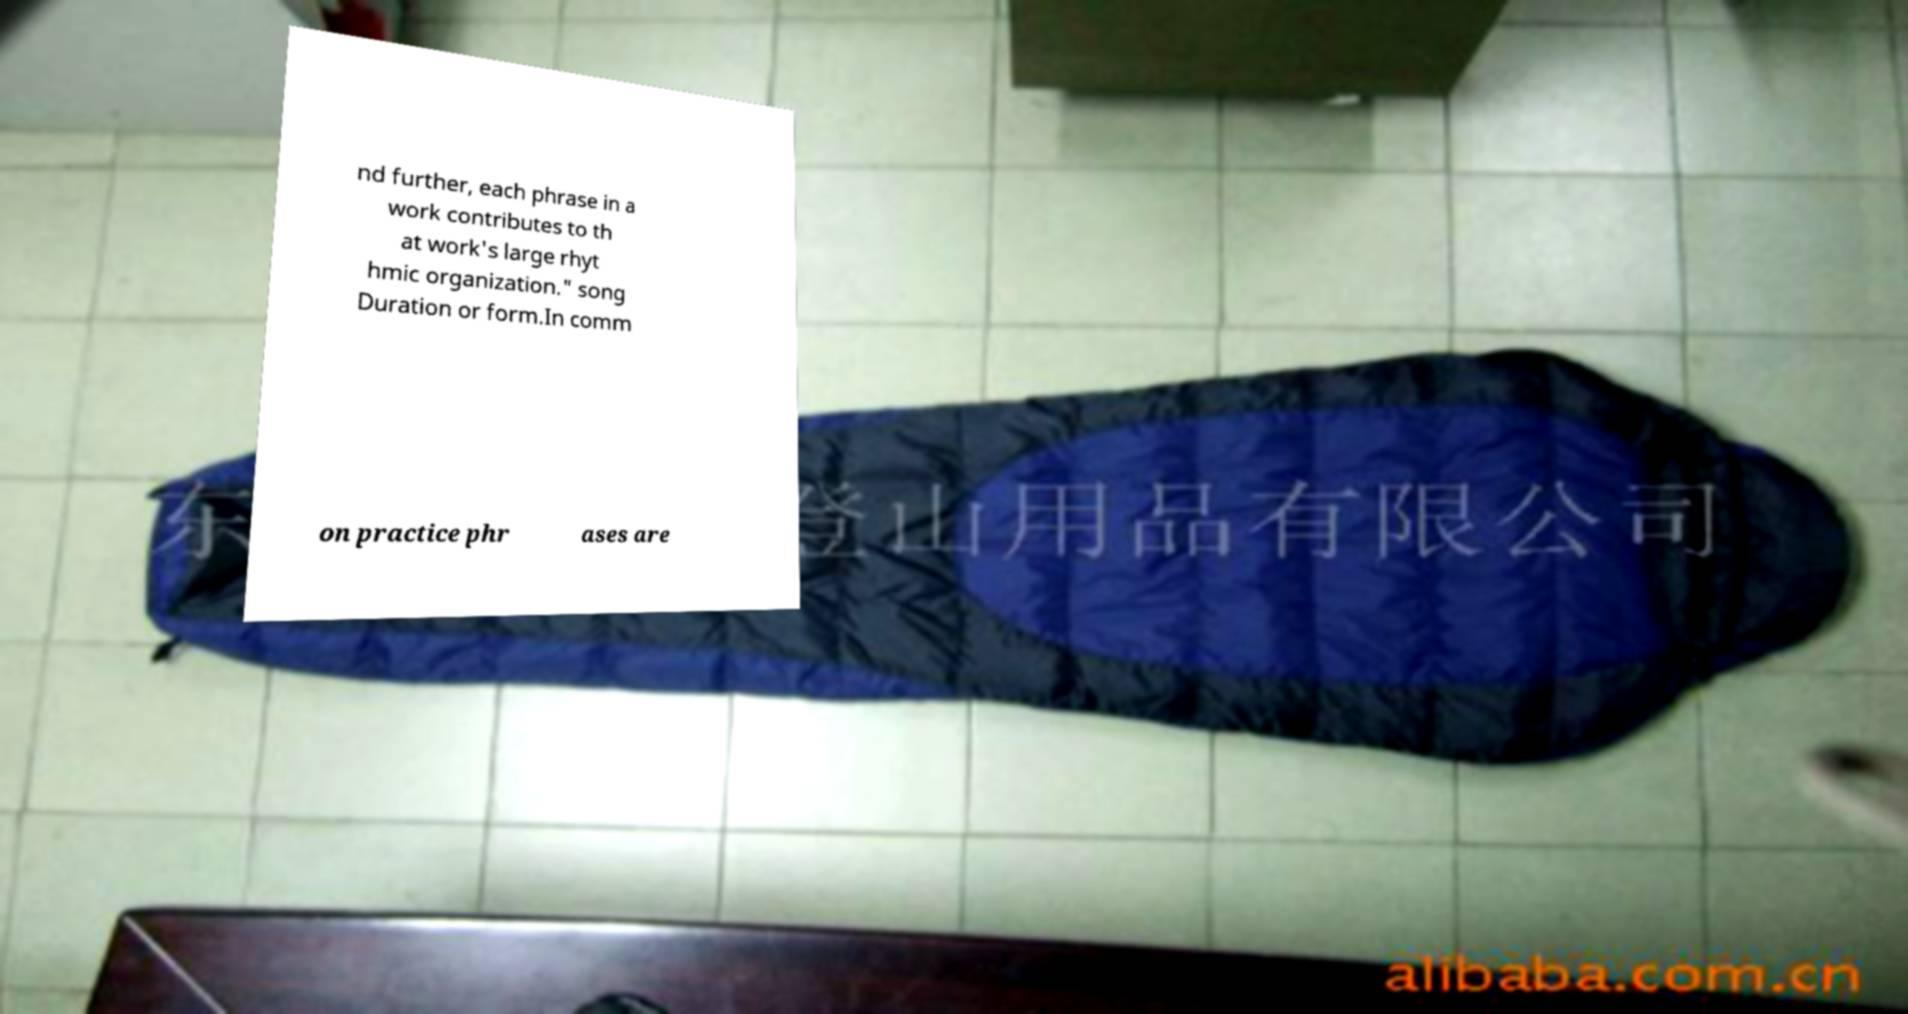Please read and relay the text visible in this image. What does it say? nd further, each phrase in a work contributes to th at work's large rhyt hmic organization." song Duration or form.In comm on practice phr ases are 